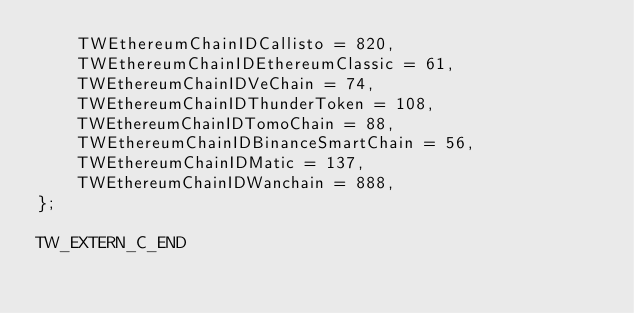<code> <loc_0><loc_0><loc_500><loc_500><_C_>    TWEthereumChainIDCallisto = 820,
    TWEthereumChainIDEthereumClassic = 61,
    TWEthereumChainIDVeChain = 74,
    TWEthereumChainIDThunderToken = 108,
    TWEthereumChainIDTomoChain = 88,
    TWEthereumChainIDBinanceSmartChain = 56,
    TWEthereumChainIDMatic = 137,
    TWEthereumChainIDWanchain = 888,
};

TW_EXTERN_C_END
</code> 